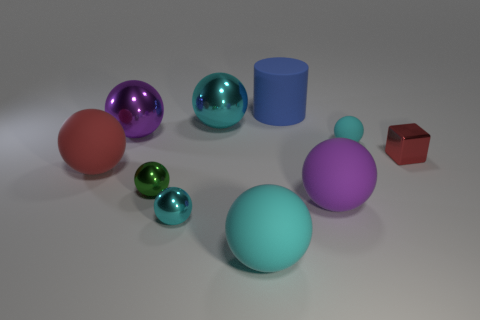Subtract all cyan balls. How many were subtracted if there are1cyan balls left? 3 Subtract all large balls. How many balls are left? 3 Subtract all red balls. How many balls are left? 7 Subtract 1 blocks. How many blocks are left? 0 Subtract all red blocks. How many cyan spheres are left? 4 Subtract all gray balls. Subtract all yellow blocks. How many balls are left? 8 Subtract 1 red cubes. How many objects are left? 9 Subtract all cylinders. How many objects are left? 9 Subtract all cyan things. Subtract all tiny cyan metallic spheres. How many objects are left? 5 Add 5 small green things. How many small green things are left? 6 